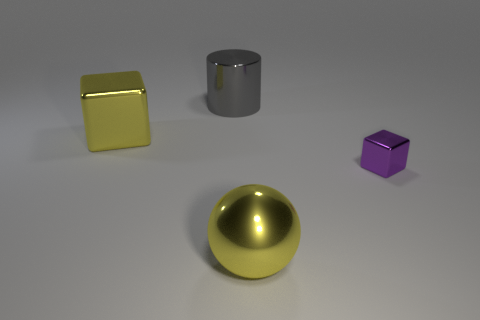Add 3 small purple metal objects. How many objects exist? 7 Subtract all cylinders. How many objects are left? 3 Add 1 gray shiny objects. How many gray shiny objects are left? 2 Add 4 big rubber blocks. How many big rubber blocks exist? 4 Subtract 0 cyan blocks. How many objects are left? 4 Subtract all large things. Subtract all brown metallic balls. How many objects are left? 1 